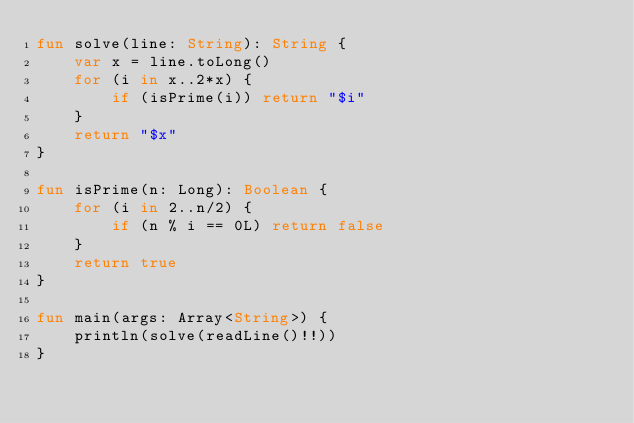<code> <loc_0><loc_0><loc_500><loc_500><_Kotlin_>fun solve(line: String): String {
    var x = line.toLong()
    for (i in x..2*x) {
        if (isPrime(i)) return "$i"
    }
    return "$x"
}

fun isPrime(n: Long): Boolean {
    for (i in 2..n/2) {
        if (n % i == 0L) return false
    }
    return true
}

fun main(args: Array<String>) {
    println(solve(readLine()!!))
}</code> 